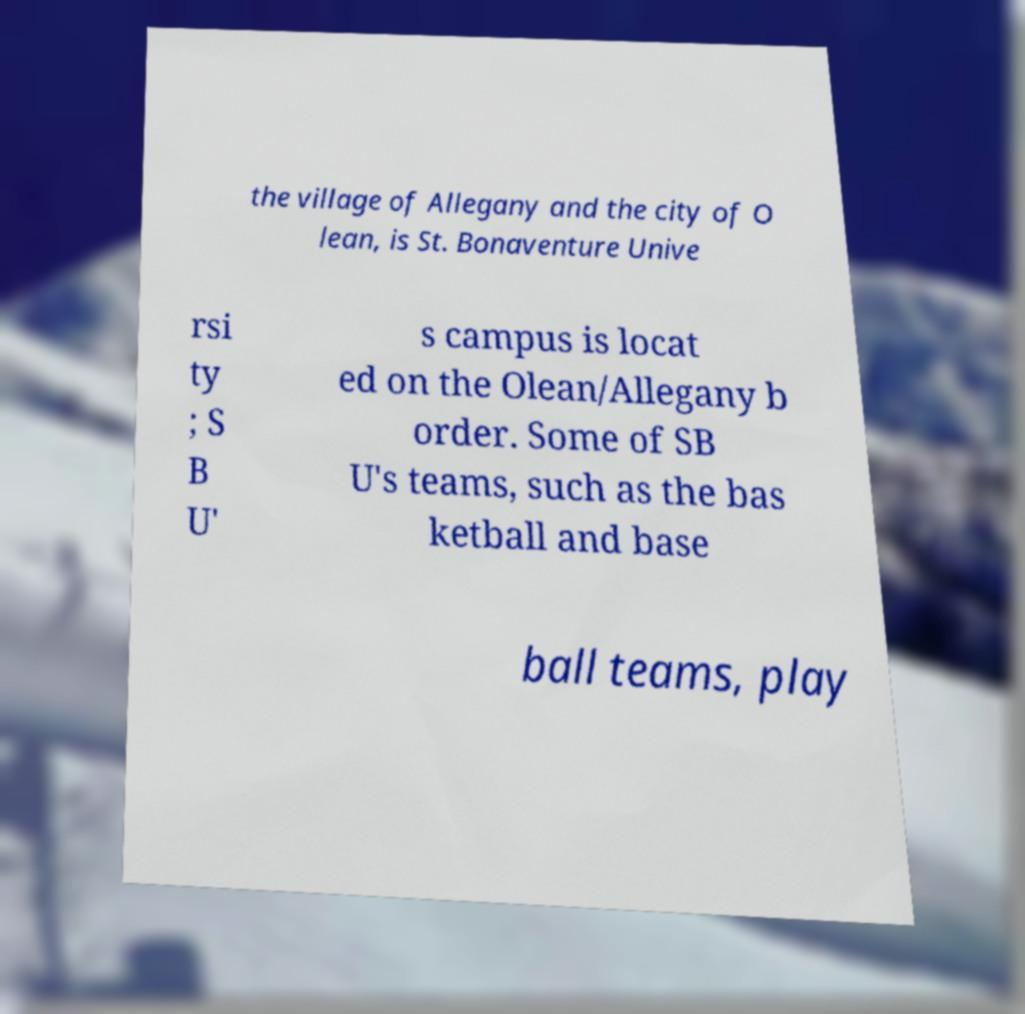What messages or text are displayed in this image? I need them in a readable, typed format. the village of Allegany and the city of O lean, is St. Bonaventure Unive rsi ty ; S B U' s campus is locat ed on the Olean/Allegany b order. Some of SB U's teams, such as the bas ketball and base ball teams, play 